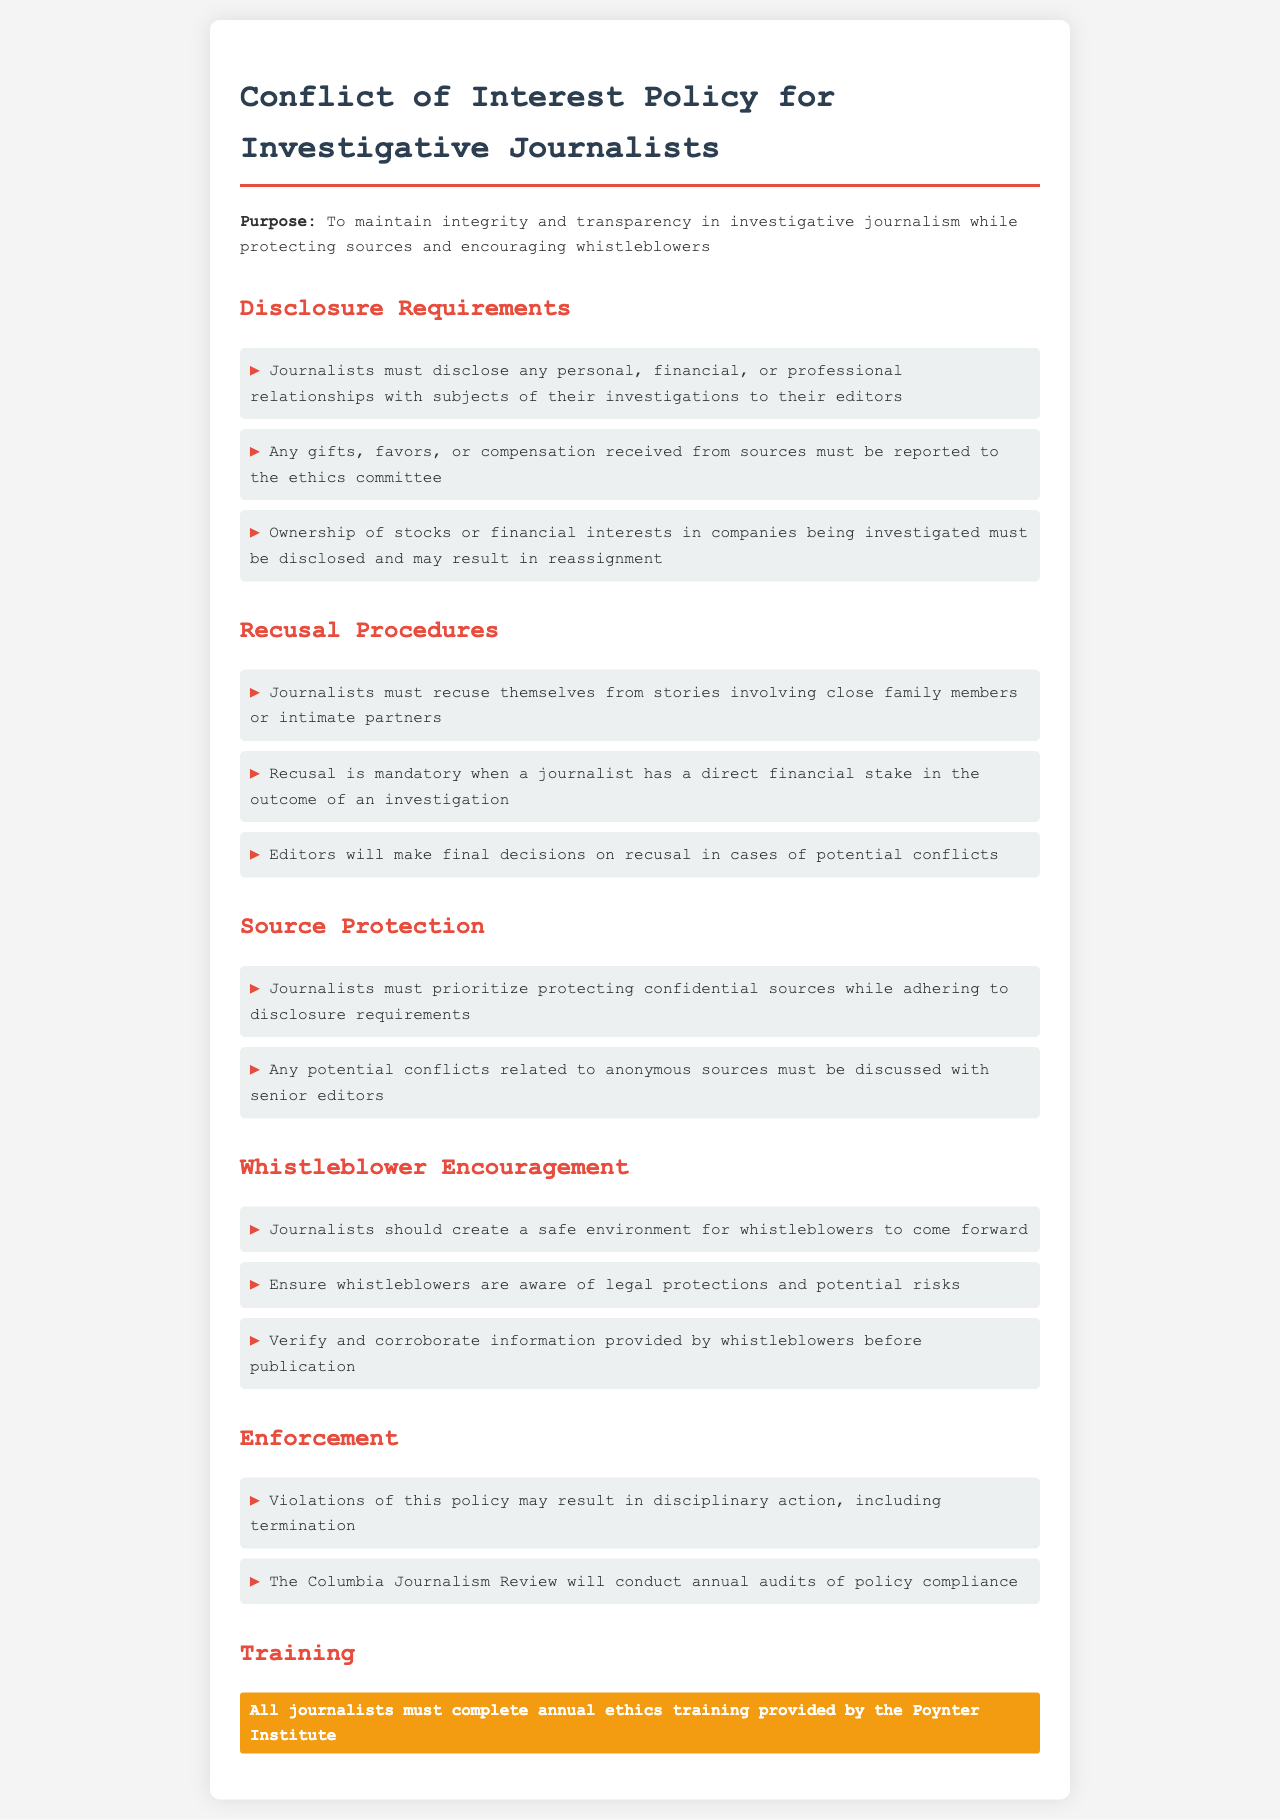What is the purpose of the policy? The purpose is to maintain integrity and transparency in investigative journalism while protecting sources and encouraging whistleblowers.
Answer: Integrity and transparency What must journalists disclose to their editors? Journalists must disclose any personal, financial, or professional relationships with subjects of their investigations.
Answer: Relationships What is mandatory for journalists with a financial stake? Recusal is mandatory when a journalist has a direct financial stake in the outcome of an investigation.
Answer: Recusal Who conducts annual audits of policy compliance? The Columbia Journalism Review will conduct annual audits of policy compliance.
Answer: Columbia Journalism Review What type of training must all journalists complete annually? All journalists must complete annual ethics training provided by the Poynter Institute.
Answer: Ethics training What should journalists do to create a safe environment for whistleblowers? Journalists should create a safe environment for whistleblowers to come forward.
Answer: Safe environment What happens if this policy is violated? Violations of this policy may result in disciplinary action, including termination.
Answer: Disciplinary action What must be reported to the ethics committee? Any gifts, favors, or compensation received from sources must be reported to the ethics committee.
Answer: Gifts and compensation What is a requirement related to anonymous sources? Any potential conflicts related to anonymous sources must be discussed with senior editors.
Answer: Discuss with senior editors 